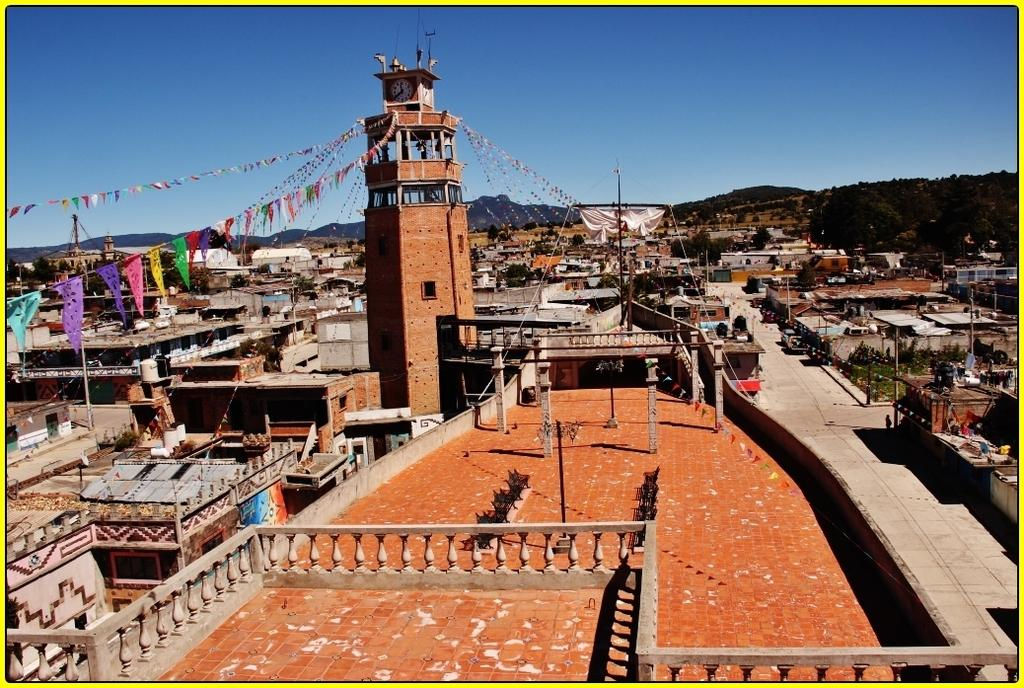What type of structures can be seen in the image? There are buildings in the image. What is hanging from the clock tower in the image? There are decorative flags hanging from the clock tower in the image. What can be used for transportation in the image? There are roads in the image, which can be used for transportation. What type of vegetation is present in the image? There are trees in the image. What type of infrastructure is present in the image? There are electric towers with cables in the image. What else can be seen in the image besides the mentioned elements? There are objects in the image. What type of natural landform is visible in the image? There are mountains in the image. Can you tell me how many pickles are on the roof of the building in the image? There are no pickles present in the image; it features buildings, decorative flags, roads, trees, electric towers, and mountains. What type of building is located in the tub in the image? There is no tub or building in the tub present in the image. 